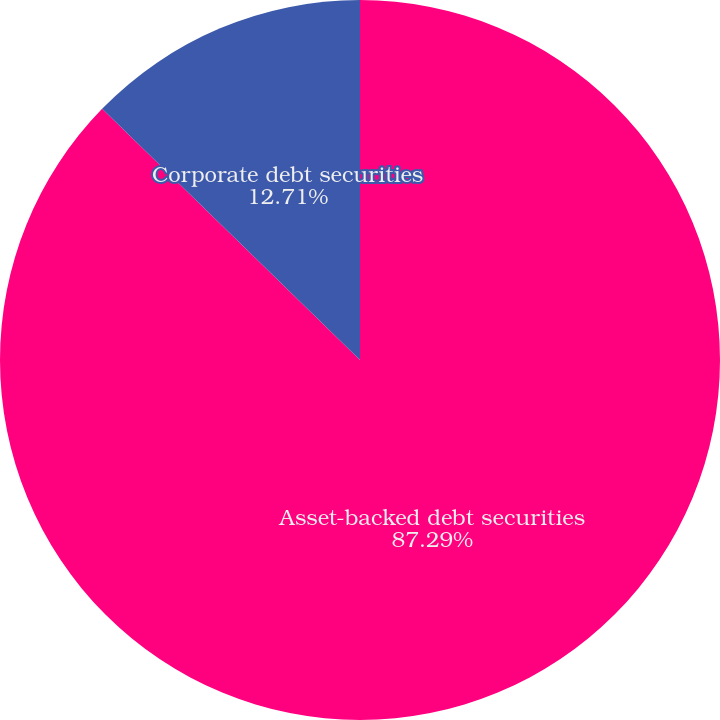Convert chart to OTSL. <chart><loc_0><loc_0><loc_500><loc_500><pie_chart><fcel>Asset-backed debt securities<fcel>Corporate debt securities<nl><fcel>87.29%<fcel>12.71%<nl></chart> 